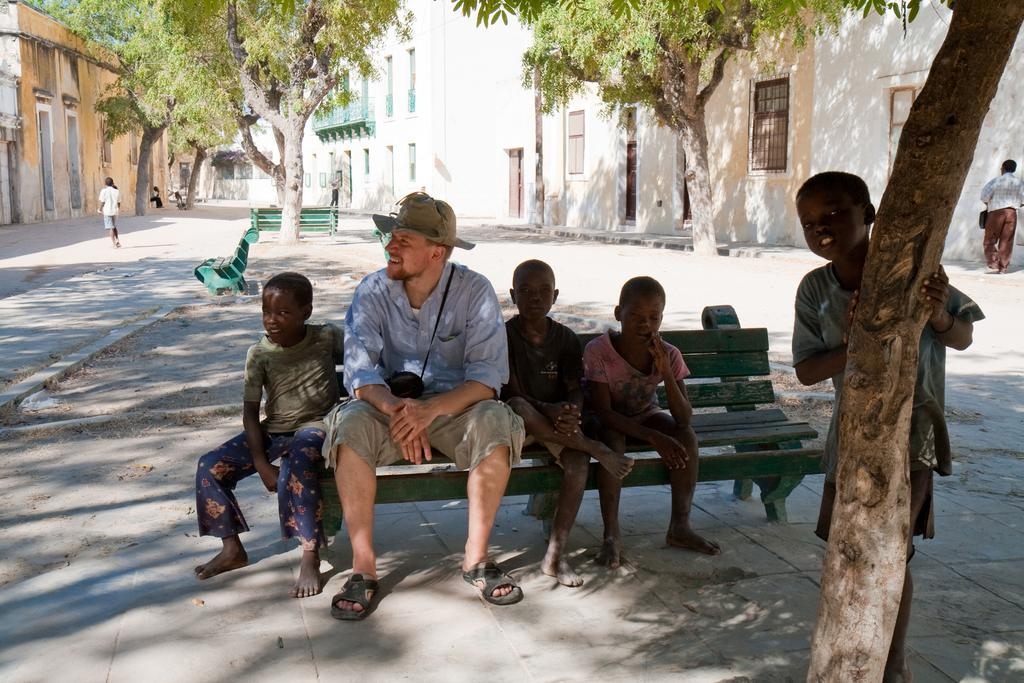What are the people in the image doing? There are persons sitting on a bench and two persons standing in the image. What can be seen in the background of the image? There are buildings, trees, and other persons in the background. Is there any indication of transportation in the image? Yes, there is a road visible in the image. What type of lead is the beginner using to fuel their creativity in the image? There is no indication of a lead, beginner, or creativity in the image; it simply shows people sitting and standing with a background of buildings, trees, and a road. 